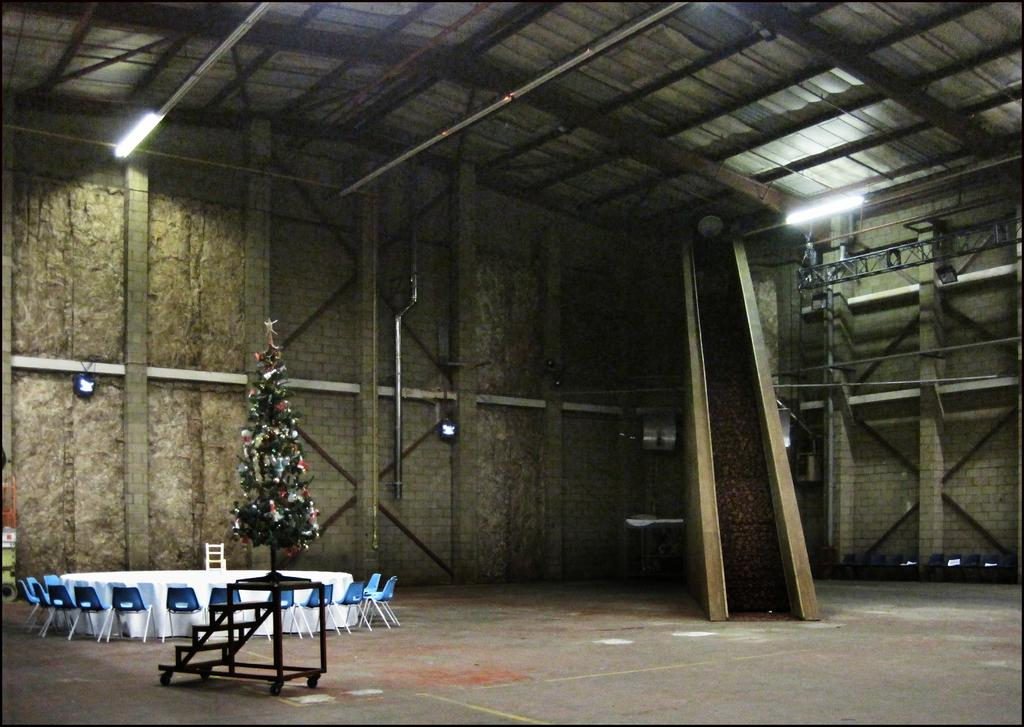What is located at the top of the image? There is a light at the top of the image. What is behind the light in the image? It is a Christmas tree behind the light. What type of furniture can be seen in the image? There is a table and chairs in the image. What type of range is visible in the image? There is no range present in the image. How is the glue being used in the image? There is no glue present in the image. 